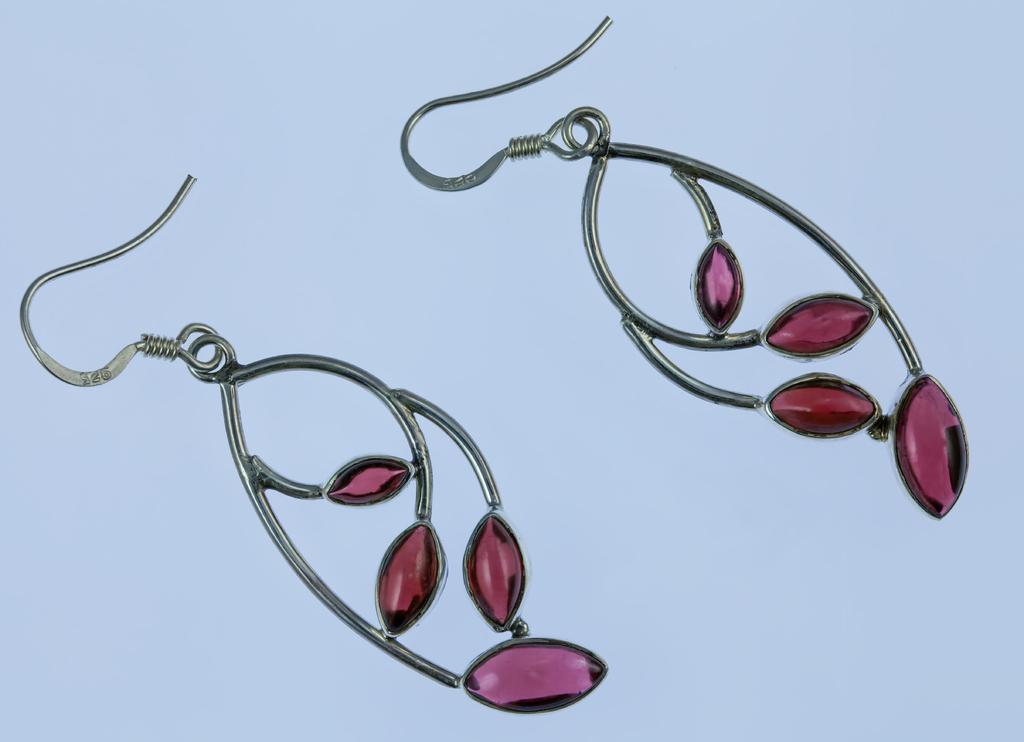Describe this image in one or two sentences. This are earrings. 